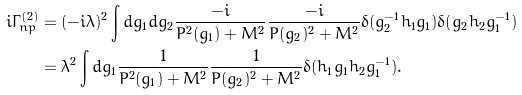Convert formula to latex. <formula><loc_0><loc_0><loc_500><loc_500>i \Gamma _ { n p } ^ { ( 2 ) } & = ( - i \lambda ) ^ { 2 } \int d g _ { 1 } d g _ { 2 } \frac { - i } { P ^ { 2 } ( g _ { 1 } ) + M ^ { 2 } } \frac { - i } { P ( g _ { 2 } ) ^ { 2 } + M ^ { 2 } } \delta ( g _ { 2 } ^ { - 1 } h _ { 1 } g _ { 1 } ) \delta ( g _ { 2 } h _ { 2 } g _ { 1 } ^ { - 1 } ) \\ & = \lambda ^ { 2 } \int d g _ { 1 } \frac { 1 } { P ^ { 2 } ( g _ { 1 } ) + M ^ { 2 } } \frac { 1 } { P ( g _ { 2 } ) ^ { 2 } + M ^ { 2 } } \delta ( h _ { 1 } g _ { 1 } h _ { 2 } g _ { 1 } ^ { - 1 } ) .</formula> 